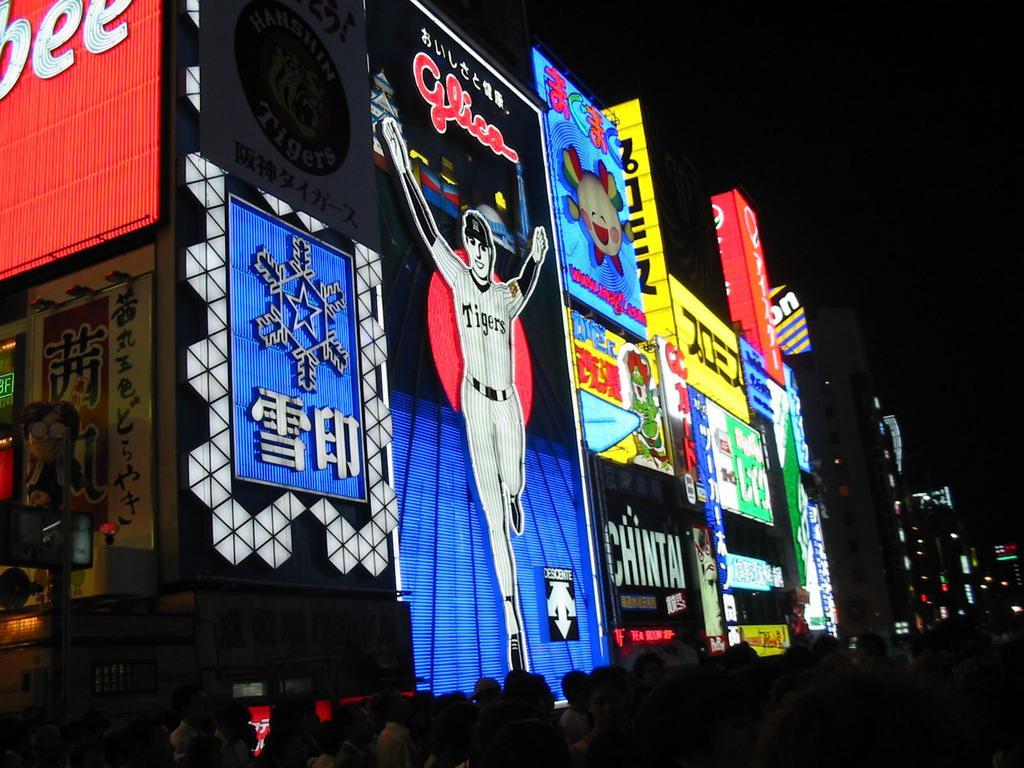In one or two sentences, can you explain what this image depicts? In this image I can see few buildings, lights, few colorful boards and few people. The image is dark. 